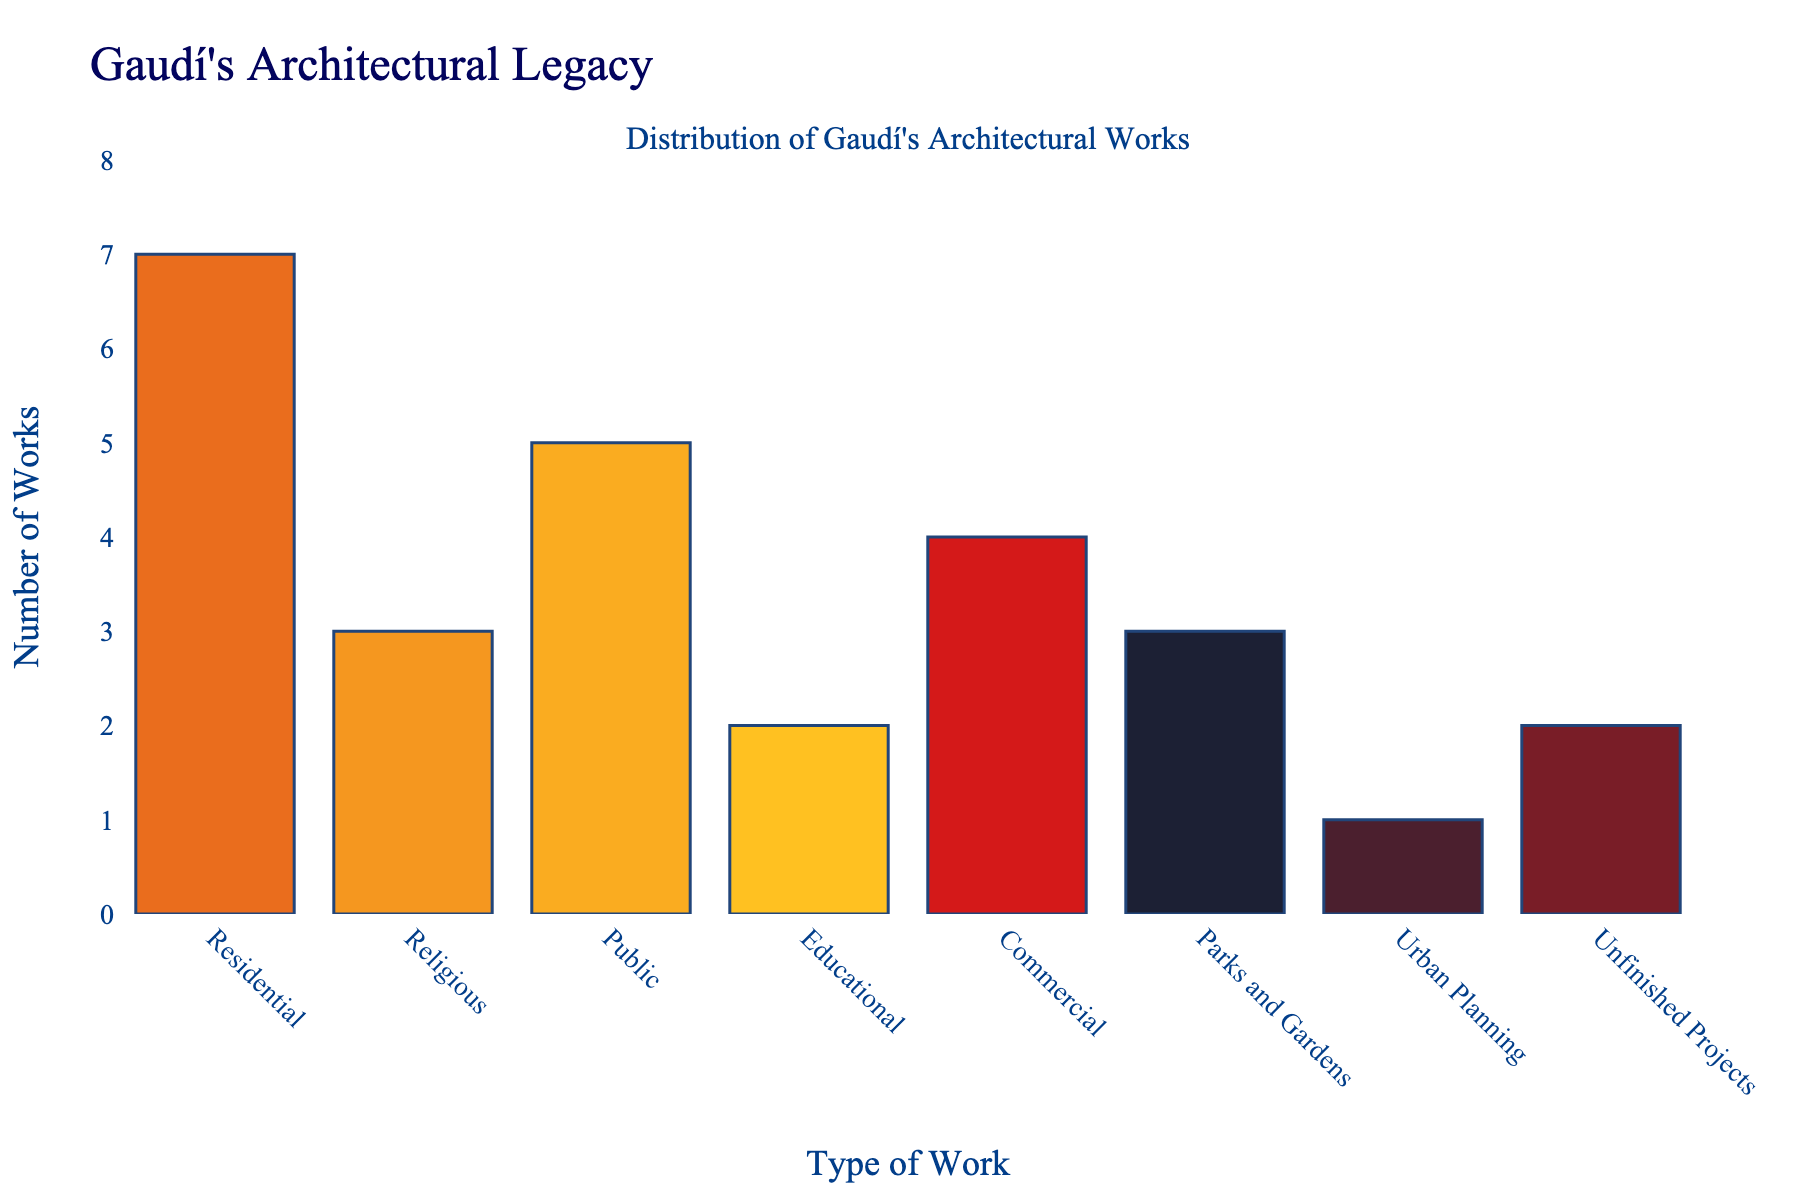Which type of work has the highest number of Gaudí's architectural works? By examining the height of the bars, the "Residential" type has the tallest bar indicating the highest count.
Answer: Residential How many more residential works did Gaudí create compared to religious works? Gaudí created 7 residential works and 3 religious works. Subtracting these gives: 7 - 3 = 4.
Answer: 4 What is the total number of educational and unfinished project works? Gaudí created 2 educational works and 2 unfinished projects. Adding these together gives: 2 + 2 = 4.
Answer: 4 Which two work types have the same number of works? Both "Religious" and "Parks and Gardens" categories have 3 works each, indicated by bars of equal height.
Answer: Religious and Parks and Gardens How many more public works are there than educational works? Gaudí created 5 public works and 2 educational works. Subtracting these gives: 5 - 2 = 3.
Answer: 3 Out of all types of Gaudí's works listed, which one has the least number of works? The "Urban Planning" category has the shortest bar, indicating the smallest number with 1 work.
Answer: Urban Planning What is the combined total of religious and parks and gardens works? Both categories have 3 works each. Adding these together: 3 + 3 = 6.
Answer: 6 Which type of work is more numerous, commercial or public? By comparing the bars, "Public" works with 5 are higher than "Commercial" works with 4.
Answer: Public What is the approximate difference in number of works between commercial works and urban planning works? The "Commercial" category has 4 works, and "Urban Planning" has 1. Subtracting: 4 - 1 = 3.
Answer: 3 What is the range of the number of architectural works across all types? The minimum number of works is 1 (Urban Planning), and the maximum is 7 (Residential). So, the range is given by: 7 - 1 = 6.
Answer: 6 